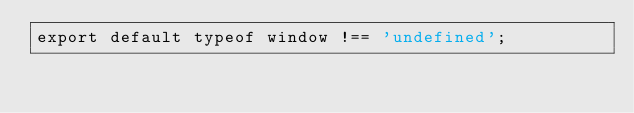<code> <loc_0><loc_0><loc_500><loc_500><_JavaScript_>export default typeof window !== 'undefined';</code> 